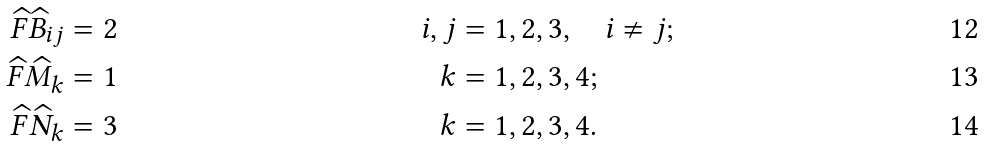<formula> <loc_0><loc_0><loc_500><loc_500>\widehat { F } \widehat { B } _ { i j } & = 2 & i , j & = 1 , 2 , 3 , \quad i \neq j ; \\ \widehat { F } \widehat { M } _ { k } & = 1 & k & = 1 , 2 , 3 , 4 ; \\ \widehat { F } \widehat { N } _ { k } & = 3 & k & = 1 , 2 , 3 , 4 .</formula> 